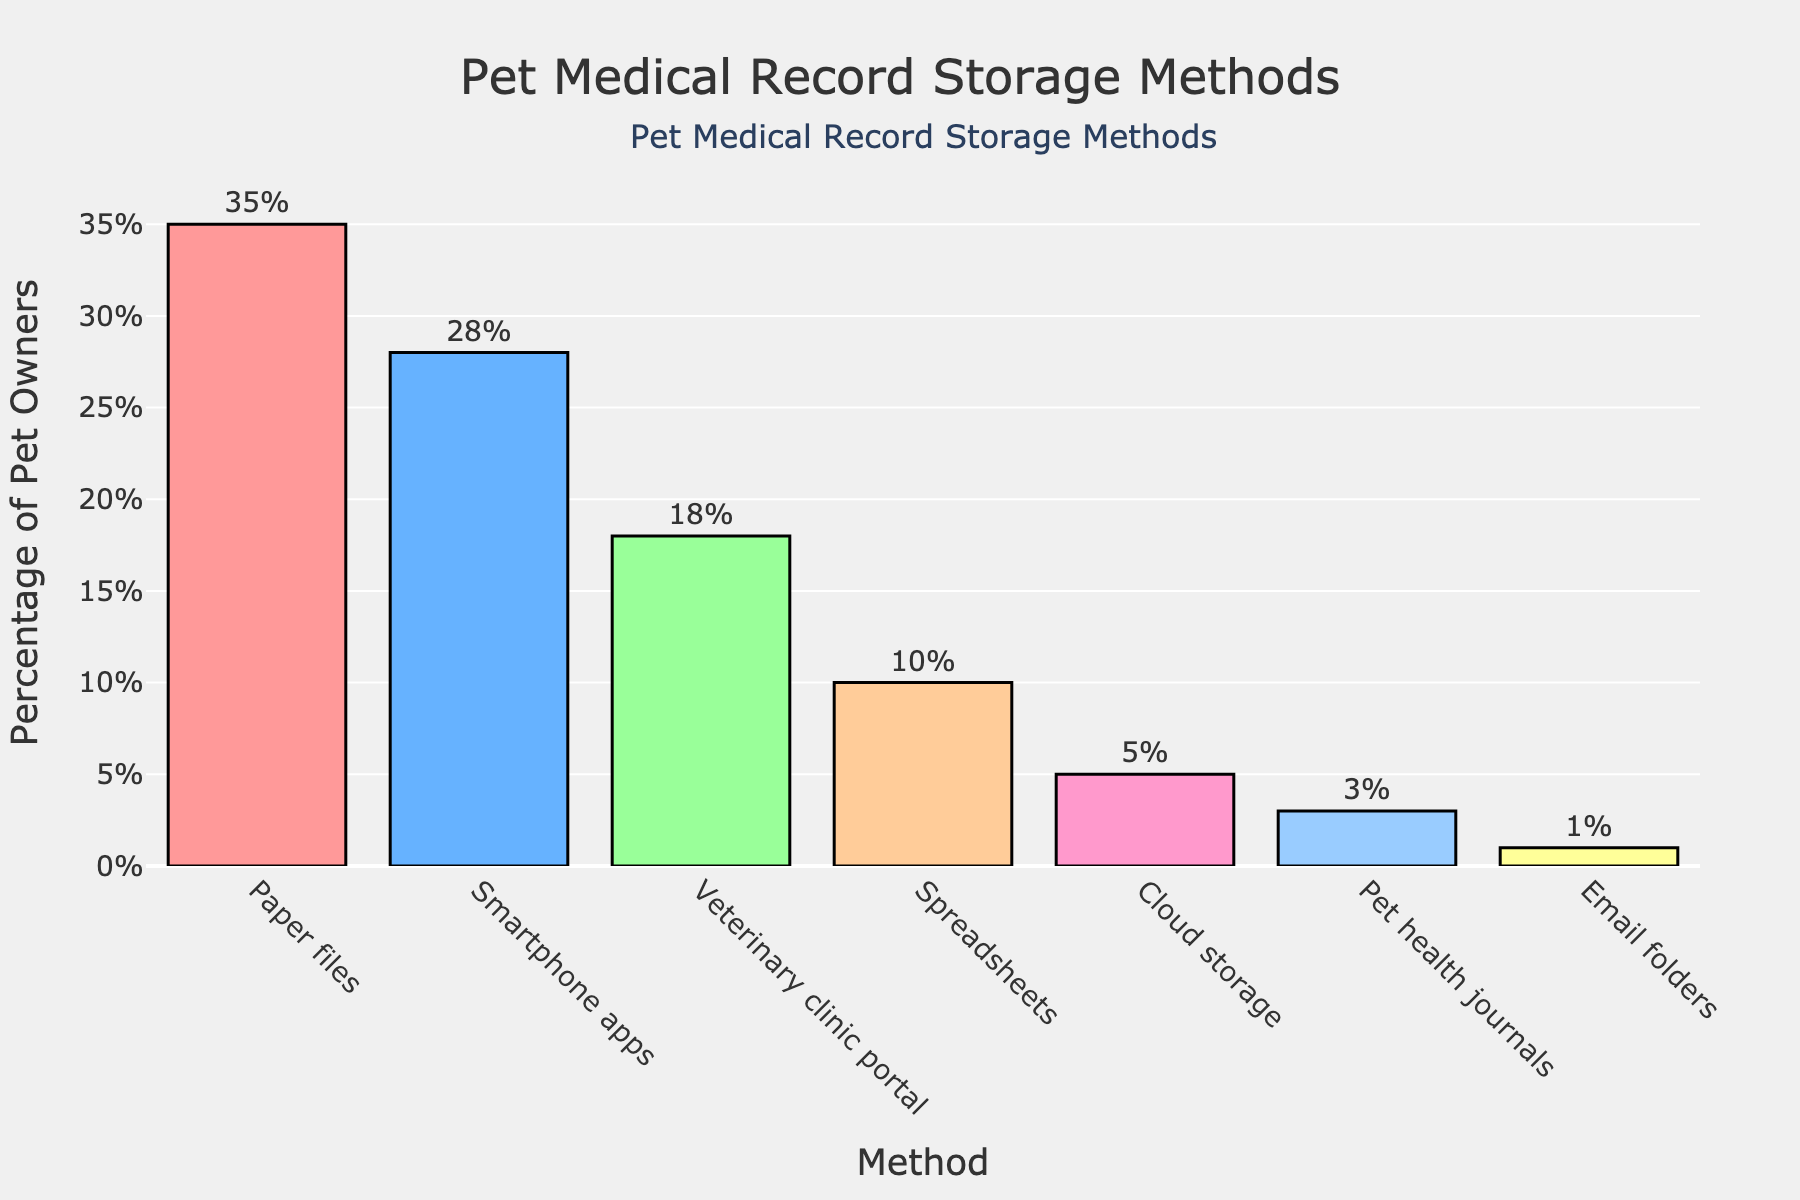Which method is the most popular for storing pet medical records? The bar chart shows the percentage of pet owners using different methods. The highest bar represents "Paper files" with 35%.
Answer: Paper files Which method is the least popular for storing pet medical records? The bar chart shows the percentage of pet owners using different methods. The lowest bar represents "Email folders" with 1%.
Answer: Email folders How much more popular are paper files compared to cloud storage? Look at the bars for "Paper files" and "Cloud storage". "Paper files" is 35%, and "Cloud storage" is 5%. Subtract 5% from 35% (35 - 5 = 30).
Answer: 30% What's the total percentage of pet owners who use either spreadsheets or cloud storage? Check the bars for "Spreadsheets" and "Cloud storage". "Spreadsheets" have 10% and "Cloud storage" has 5%. Add the percentages together (10 + 5 = 15).
Answer: 15% Which method has a percentage closest to 20%? Look for bars with percentages near 20%. The bar for "Veterinary clinic portal" shows 18%, which is the closest to 20%.
Answer: Veterinary clinic portal Are there more pet owners using smartphone apps or pet health journals? Compare the bars for "Smartphone apps" and "Pet health journals". "Smartphone apps" have 28%, and "Pet health journals" have 3%. 28% is greater than 3%.
Answer: Smartphone apps By what percentage do the use of veterinary clinic portals exceed the use of spreadsheets for storing pet medical records? Check the bars for "Veterinary clinic portal" (18%) and "Spreadsheets" (10%). Subtract 10% from 18% (18 - 10 = 8).
Answer: 8% What is the combined percentage of pet owners using either smartphone apps, veterinary clinic portals, or pet health journals? Add the percentages for "Smartphone apps" (28%), "Veterinary clinic portal" (18%), and "Pet health journals" (3%). The combined percentage is 28 + 18 + 3 = 49.
Answer: 49% Which method is represented by the blue-colored bar, and what percentage does it account for? The bar colored blue represents "Smartphone apps," and it accounts for 28%.
Answer: Smartphone apps, 28% How many methods are used by less than 10% of pet owners? Identify the bars with percentages less than 10%. These methods are "Cloud storage" (5%), "Pet health journals" (3%), and "Email folders" (1%). There are three methods in total.
Answer: 3 